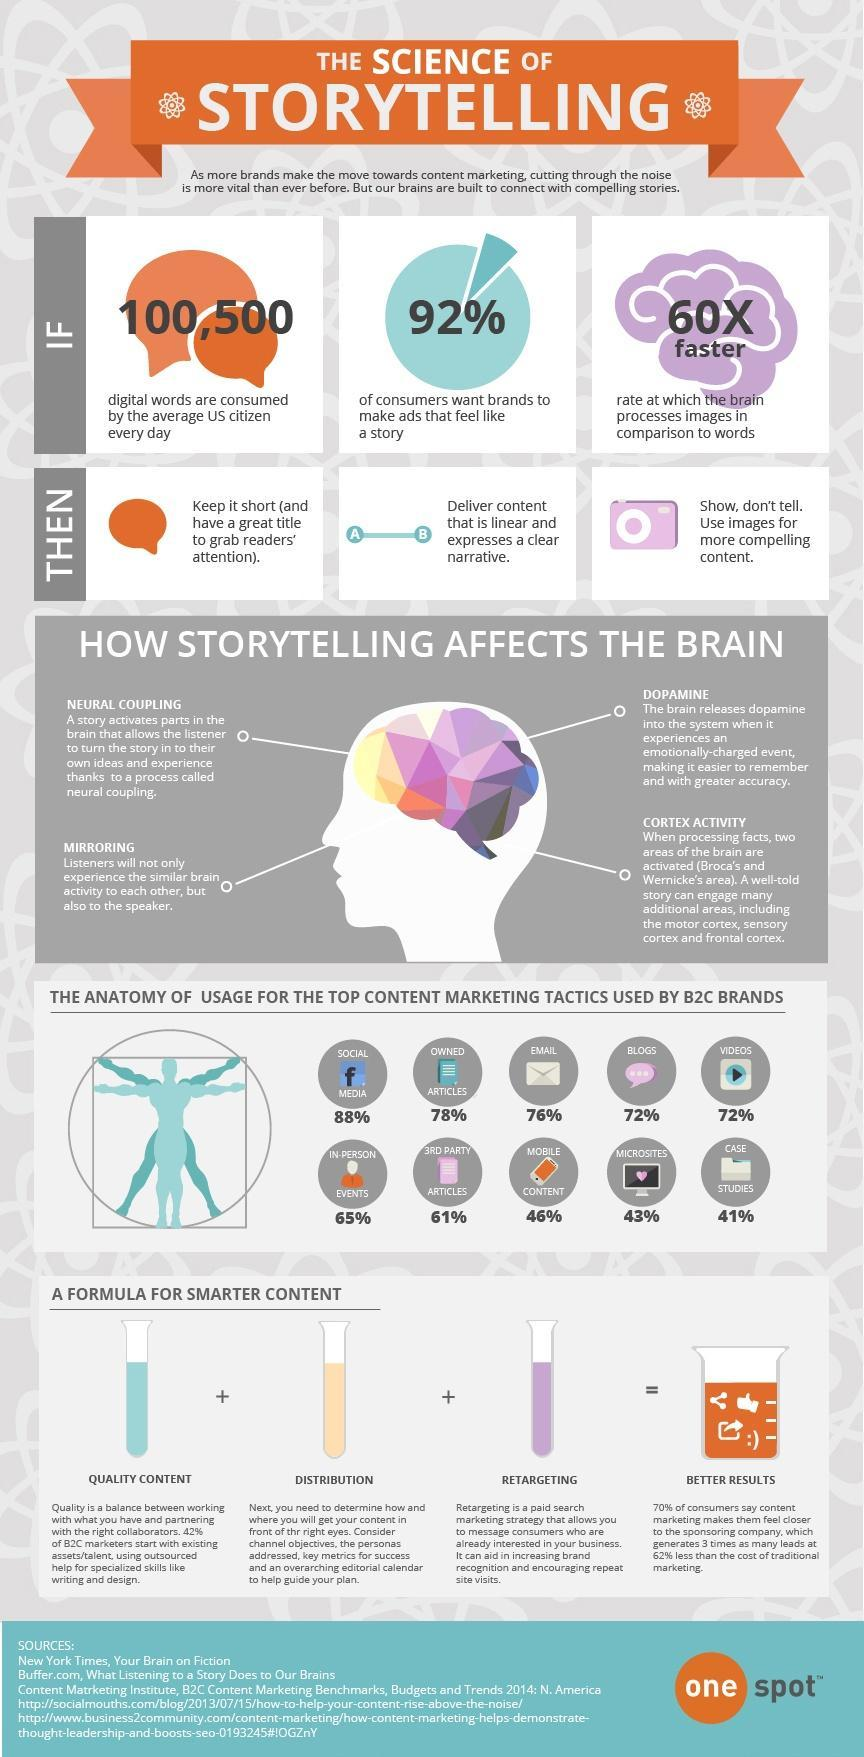What percentage of video marketing tactics are used by B2C brands in U.S.?
Answer the question with a short phrase. 72% What percentage of mobile content marketing tactics are used by B2C brands in U.S.? 46% Which content marketing tactic tool is least used by the B2C brands? CASE STUDIES What percentage of email marketing tactics are used by B2C brands in U.S.? 76% What are the formula ingredients for a smarter content creation? QUALITY CONTENT, DISTRIBUTION, RETARGETING Which top content marketing tactic tool is used by most of the B2C brands? SOCIAL MEDIA 